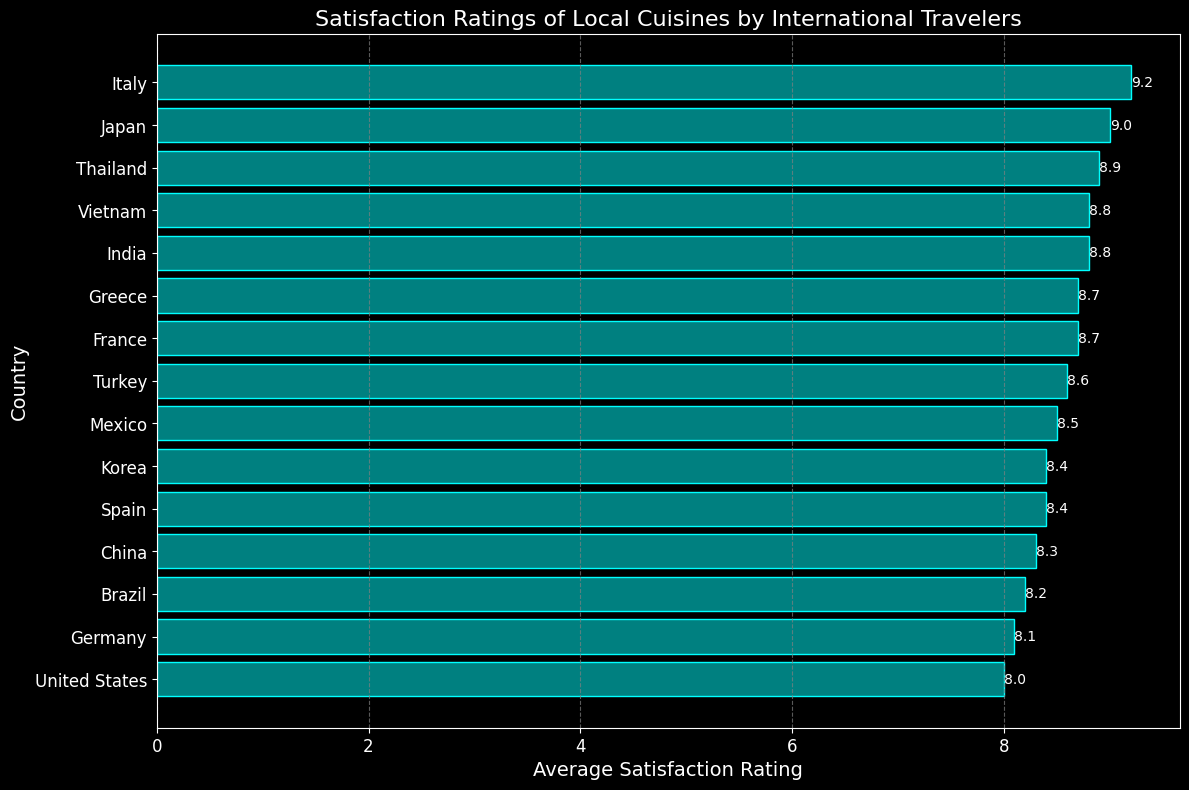Which country has the highest Average Satisfaction Rating for its local cuisine? Look at the bar that extends the farthest to the right, which represents the highest satisfaction rating. The bar for Italy (Pizza Margherita) is the longest, indicating it has the highest rating.
Answer: Italy How does the satisfaction rating for Sushi compare to that for Burgers? Compare the lengths of the bars for Japan (Sushi) and United States (Burgers). The bar for Sushi extends to 9.0, while the bar for Burgers extends to 8.0.
Answer: Sushi has a higher rating than Burgers What is the difference between the highest and lowest satisfaction ratings? Identify the maximum rating (9.2 for Italy) and the minimum rating (8.0 for United States). Subtract the minimum rating from the maximum rating: 9.2 - 8.0.
Answer: 1.2 Which three countries have the middle satisfaction ratings? First, order the countries by their satisfaction ratings. The ratings sorted are 8.0 (United States), 8.1 (Germany), 8.2 (Brazil), 8.3 (China), 8.4 (Spain & Korea), 8.5 (Mexico), 8.6 (Turkey), 8.7 (France & Greece), 8.8 (India & Vietnam), 8.9 (Thailand), 9.0 (Japan), 9.2 (Italy). The three middle countries are Spain, Korea, and Mexico.
Answer: Spain, Korea, and Mexico What is the total sum of the satisfaction ratings for countries with ratings above 8.5? Add the ratings for Italy (9.2), Japan (9.0), Thailand (8.9), Vietnam (8.8), India (8.8), France (8.7), Greece (8.7), and Turkey (8.6): 9.2 + 9.0 + 8.9 + 8.8 + 8.8 + 8.7 + 8.7 + 8.6 = 70.7.
Answer: 70.7 Which local cuisine has equal satisfaction ratings, and what are they? Look for identical bar lengths and values. France (Coq au Vin) and Greece (Moussaka) both have a rating of 8.7, as do India (Butter Chicken) and Vietnam (Pho) with a rating of 8.8.
Answer: Coq au Vin and Moussaka (8.7); Butter Chicken and Pho (8.8) What is the average satisfaction rating of the top five rated cuisines? First, identify the top five ratings, which are for Italy (9.2), Japan (9.0), Thailand (8.9), Vietnam (8.8), and India (8.8). Calculate the average: (9.2 + 9.0 + 8.9 + 8.8 + 8.8) / 5 = 8.94.
Answer: 8.94 How many countries have a satisfaction rating below 8.5? Count the bars for countries with ratings less than 8.5: United States (8.0), Germany (8.1), Brazil (8.2), China (8.3), Spain (8.4), and Korea (8.4). There are five such countries.
Answer: 5 Which country has a satisfaction rating closest to the median rating? Order the ratings and find the median. The ratings are: 8.0, 8.1, 8.2, 8.3, 8.4, 8.4, 8.5, 8.6, 8.7, 8.7, 8.8, 8.8, 8.9, 9.0, 9.2. The median is 8.5 for Mexico (Tacos).
Answer: Mexico 